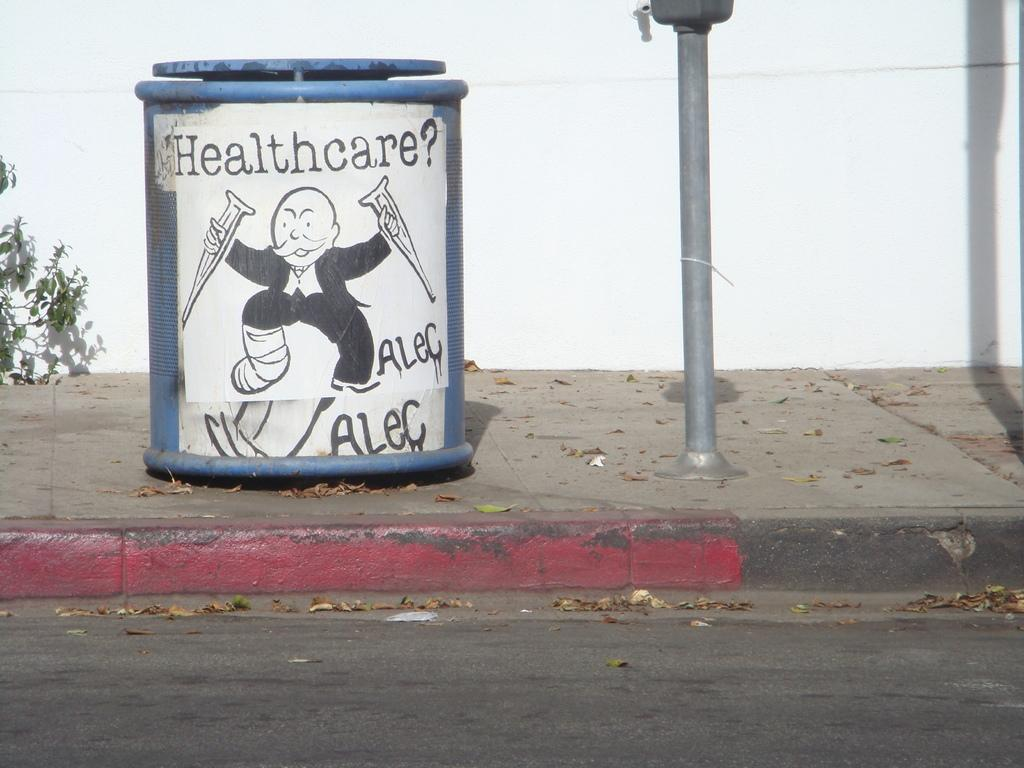<image>
Share a concise interpretation of the image provided. A garbage can that says Healthcare? and Alec with the monopoly man drawn on it. 